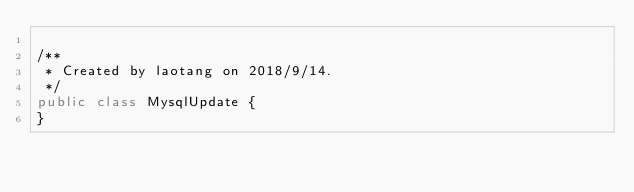Convert code to text. <code><loc_0><loc_0><loc_500><loc_500><_Java_>
/**
 * Created by laotang on 2018/9/14.
 */
public class MysqlUpdate {
}
</code> 